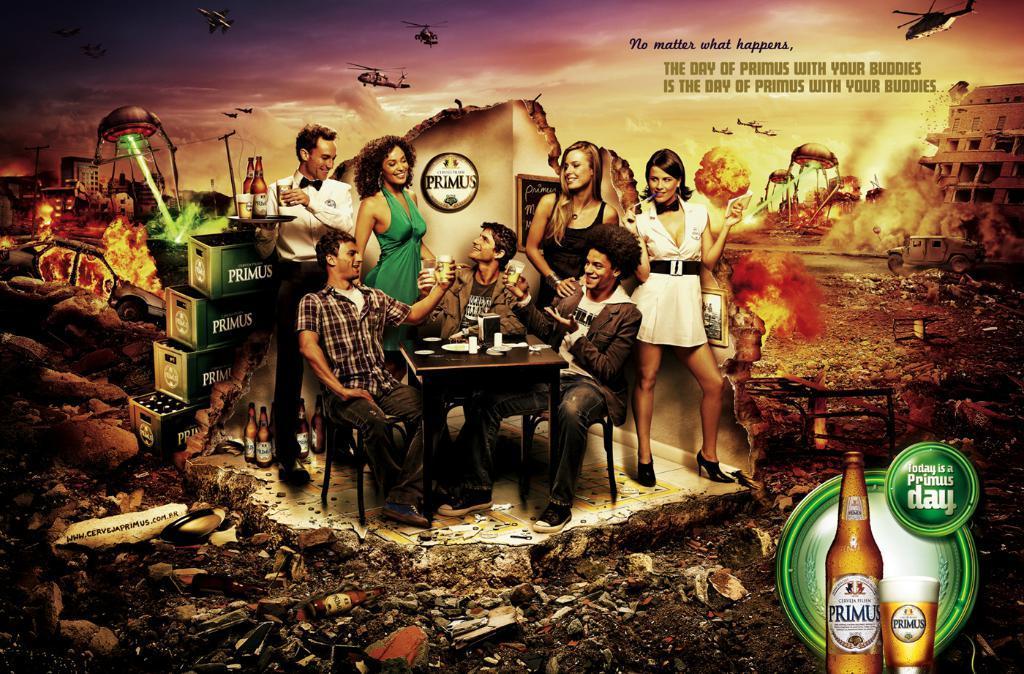Describe this image in one or two sentences. This is a magazine, there are group of people. Three people are sitting and the remaining are standing on the floor. In front of this people there is a table on the table there is a plate, cup. The people are holding the glasses. The man in white shirt holding a tray. Background of this people is a battlefield. 